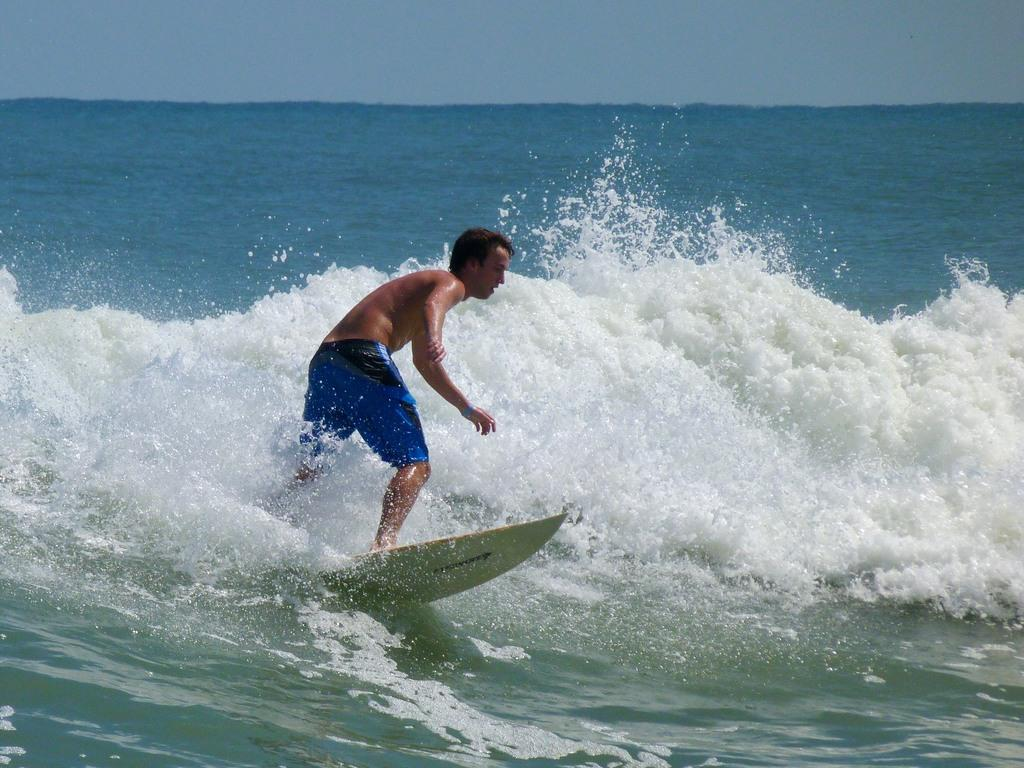Who is the person in the image? There is a man in the image. What is the man doing in the image? The man is on a surfboard and surfing in the waves. What can be seen in the background of the image? There is water and the sky visible in the background of the image. How many spiders are crawling on the pan in the image? There are no spiders or pans present in the image. 